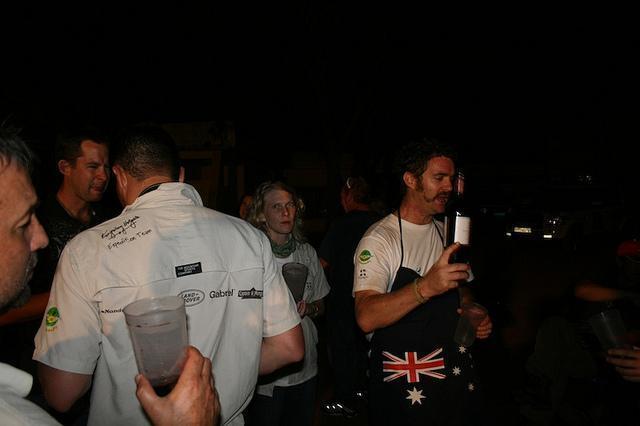How many women do you see?
Give a very brief answer. 1. How many bottles are seen?
Give a very brief answer. 1. How many people?
Give a very brief answer. 5. How many umbrellas are visible in this photo?
Give a very brief answer. 0. How many bald men are shown?
Give a very brief answer. 0. How many people are in the picture?
Give a very brief answer. 6. How many people are there?
Give a very brief answer. 6. 